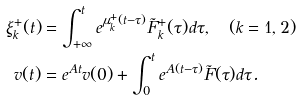Convert formula to latex. <formula><loc_0><loc_0><loc_500><loc_500>\xi ^ { + } _ { k } ( t ) & = \int ^ { t } _ { + \infty } e ^ { \mu ^ { + } _ { k } ( t - \tau ) } \tilde { F } ^ { + } _ { k } ( \tau ) d \tau , \quad ( k = 1 , 2 ) \\ v ( t ) & = e ^ { A t } v ( 0 ) + \int ^ { t } _ { 0 } e ^ { A ( t - \tau ) } \tilde { F } ( \tau ) d \tau .</formula> 